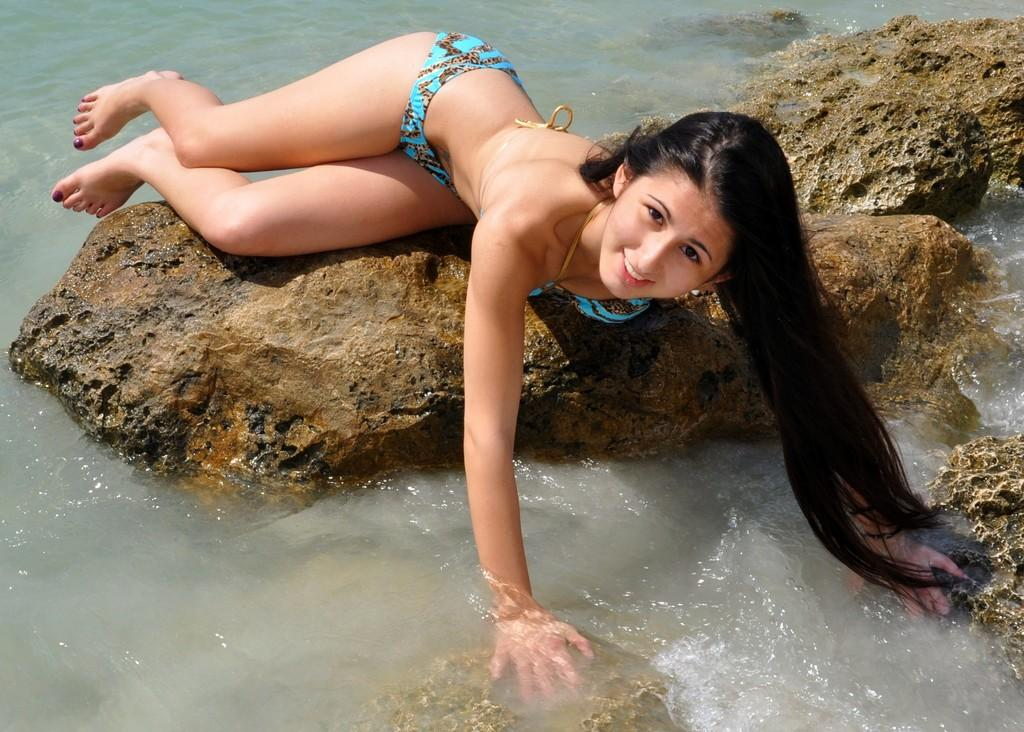Who is present in the image? There is a woman in the image. What is the woman wearing? The woman is wearing a bikini. Where is the woman located in the image? The woman is on a rock. What is the surrounding environment like? There are rocks around the woman, and there is water visible in the image. What type of cream is the woman using to spy on the rocks in the image? There is no cream or spying activity present in the image. The woman is simply sitting on a rock in her bikini, surrounded by other rocks and water. 